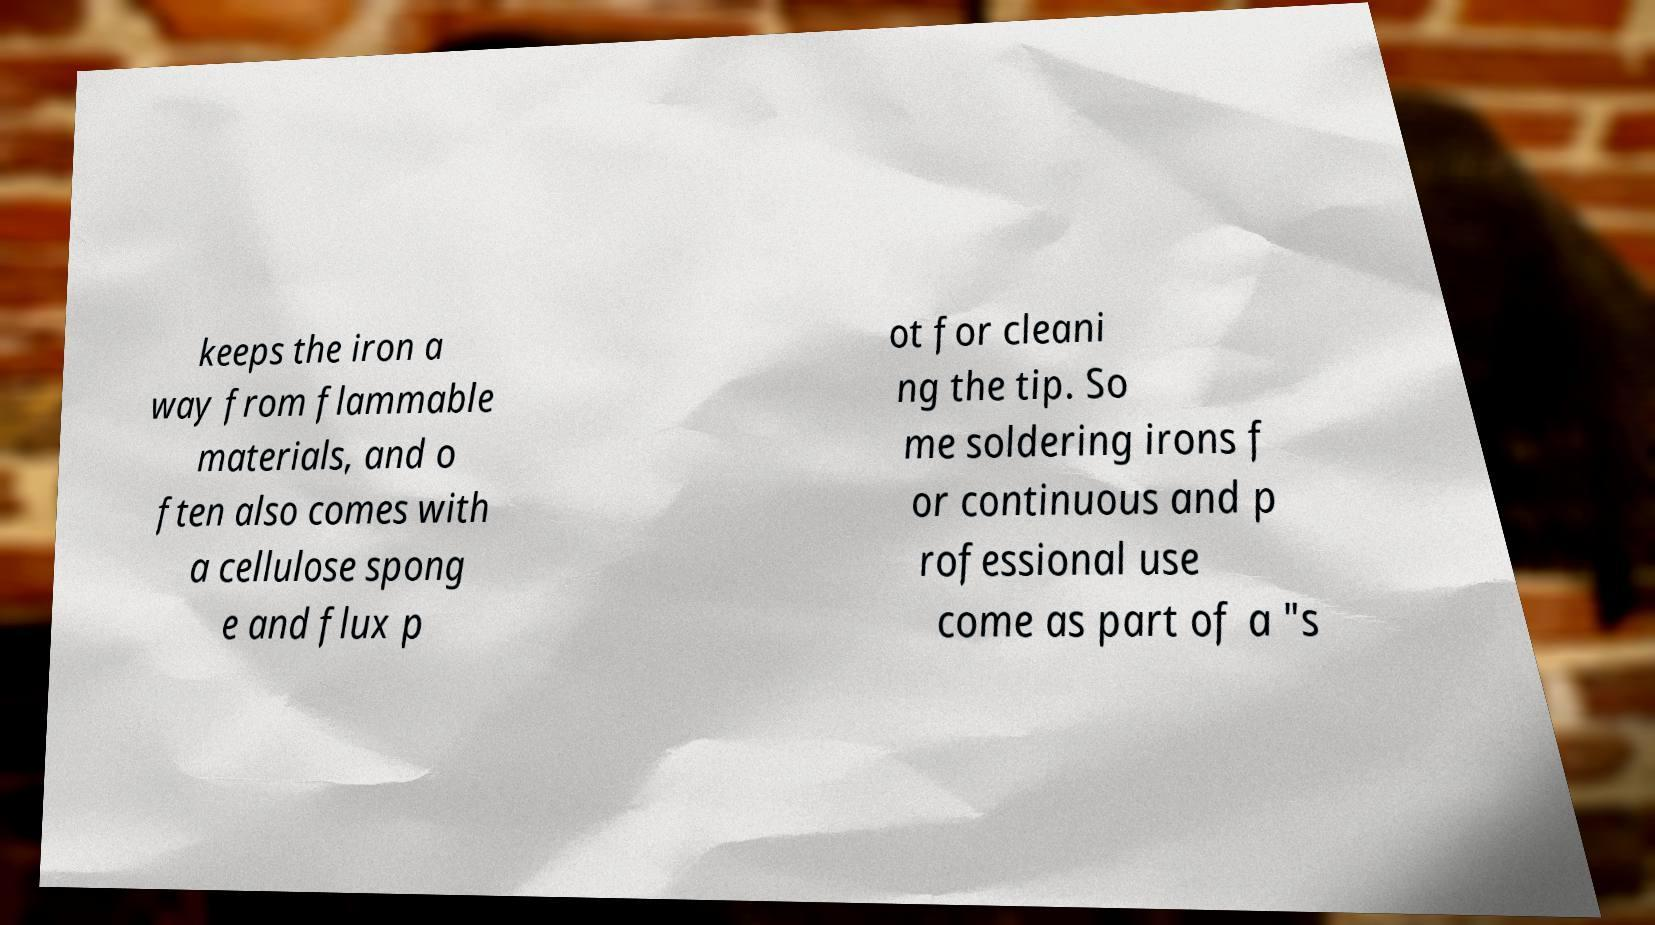Please identify and transcribe the text found in this image. keeps the iron a way from flammable materials, and o ften also comes with a cellulose spong e and flux p ot for cleani ng the tip. So me soldering irons f or continuous and p rofessional use come as part of a "s 